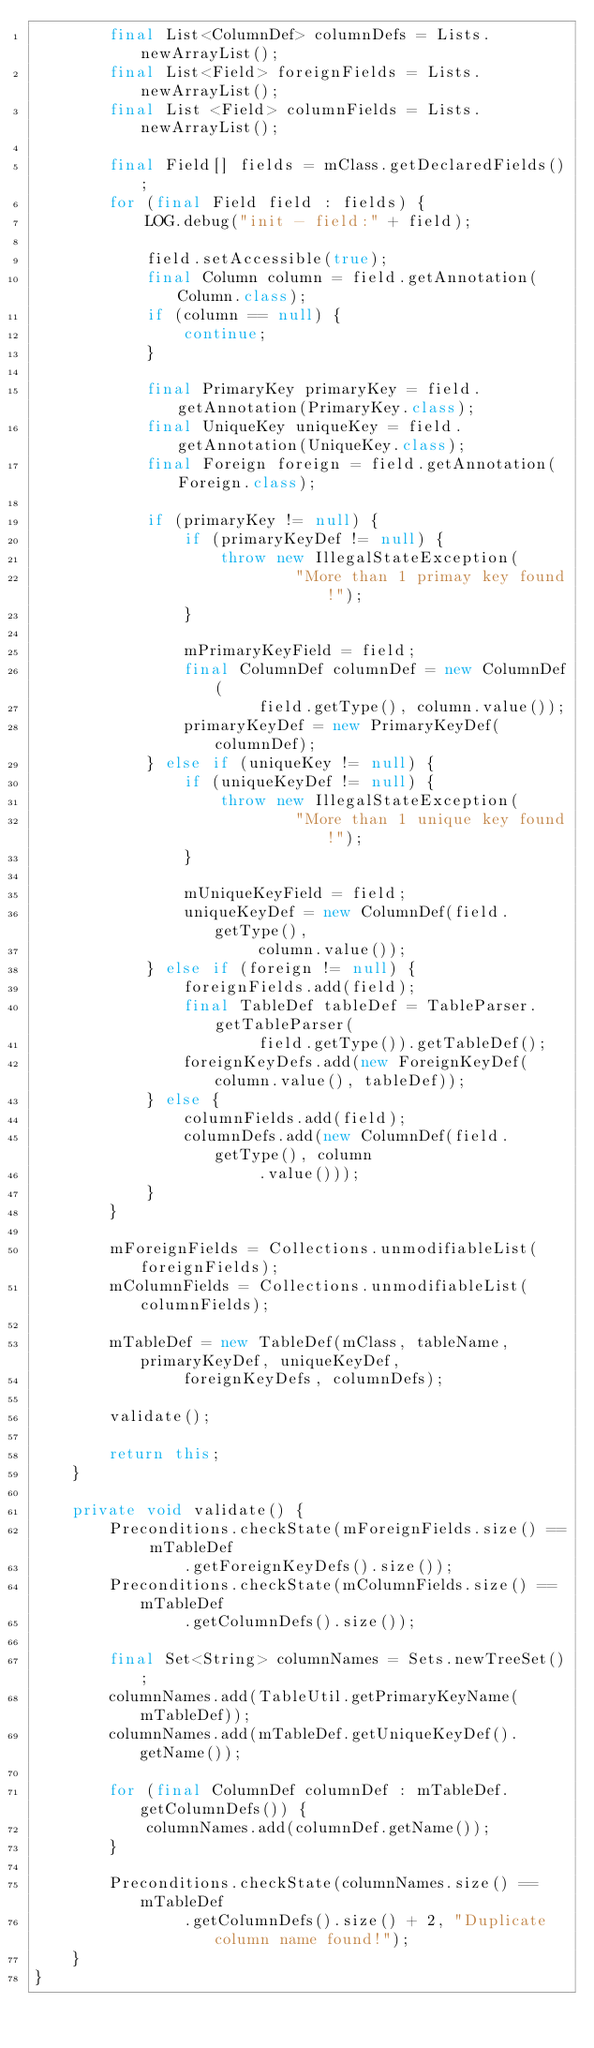<code> <loc_0><loc_0><loc_500><loc_500><_Java_>        final List<ColumnDef> columnDefs = Lists.newArrayList();
        final List<Field> foreignFields = Lists.newArrayList();
        final List <Field> columnFields = Lists.newArrayList();

        final Field[] fields = mClass.getDeclaredFields();
        for (final Field field : fields) {
            LOG.debug("init - field:" + field);

            field.setAccessible(true);
            final Column column = field.getAnnotation(Column.class);
            if (column == null) {
                continue;
            }

            final PrimaryKey primaryKey = field.getAnnotation(PrimaryKey.class);
            final UniqueKey uniqueKey = field.getAnnotation(UniqueKey.class);
            final Foreign foreign = field.getAnnotation(Foreign.class);

            if (primaryKey != null) {
                if (primaryKeyDef != null) {
                    throw new IllegalStateException(
                            "More than 1 primay key found!");
                }

                mPrimaryKeyField = field;
                final ColumnDef columnDef = new ColumnDef(
                        field.getType(), column.value());
                primaryKeyDef = new PrimaryKeyDef(columnDef);
            } else if (uniqueKey != null) {
                if (uniqueKeyDef != null) {
                    throw new IllegalStateException(
                            "More than 1 unique key found!");
                }

                mUniqueKeyField = field;
                uniqueKeyDef = new ColumnDef(field.getType(),
                        column.value());
            } else if (foreign != null) {
                foreignFields.add(field);
                final TableDef tableDef = TableParser.getTableParser(
                        field.getType()).getTableDef();
                foreignKeyDefs.add(new ForeignKeyDef(column.value(), tableDef));
            } else {
                columnFields.add(field);
                columnDefs.add(new ColumnDef(field.getType(), column
                        .value()));
            }
        }

        mForeignFields = Collections.unmodifiableList(foreignFields);
        mColumnFields = Collections.unmodifiableList(columnFields);

        mTableDef = new TableDef(mClass, tableName, primaryKeyDef, uniqueKeyDef,
                foreignKeyDefs, columnDefs);

        validate();

        return this;
    }

    private void validate() {
        Preconditions.checkState(mForeignFields.size() == mTableDef
                .getForeignKeyDefs().size());
        Preconditions.checkState(mColumnFields.size() == mTableDef
                .getColumnDefs().size());

        final Set<String> columnNames = Sets.newTreeSet();
        columnNames.add(TableUtil.getPrimaryKeyName(mTableDef));
        columnNames.add(mTableDef.getUniqueKeyDef().getName());

        for (final ColumnDef columnDef : mTableDef.getColumnDefs()) {
            columnNames.add(columnDef.getName());
        }

        Preconditions.checkState(columnNames.size() == mTableDef
                .getColumnDefs().size() + 2, "Duplicate column name found!");
    }
}
</code> 